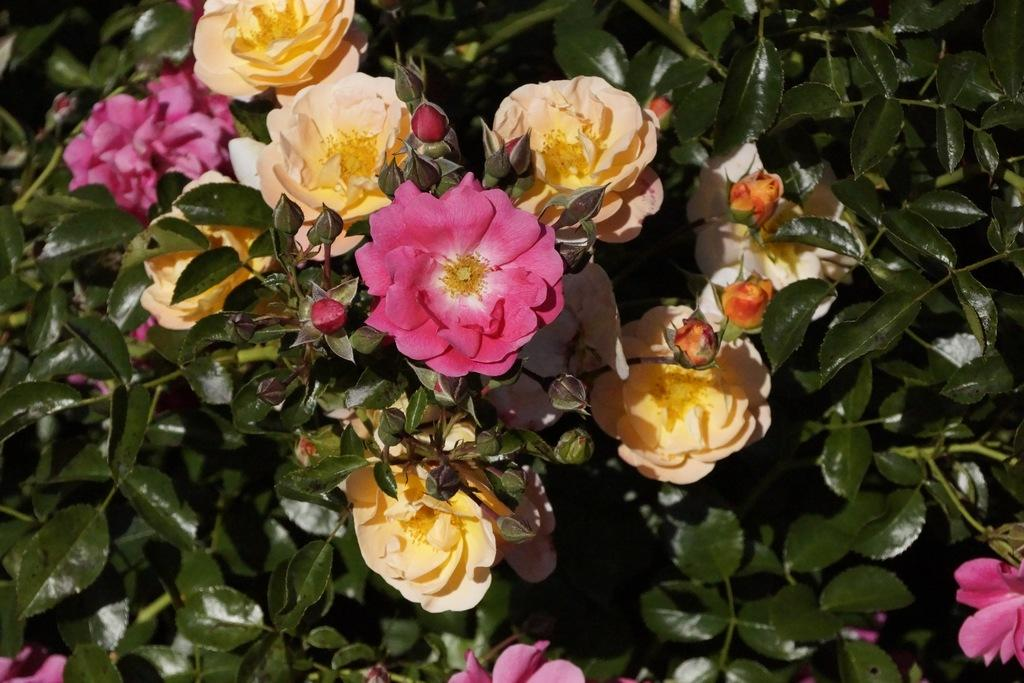What type of plants can be seen in the image? There are colorful flowers in the image. Can you describe the stage of growth for some of the flowers? Yes, there are buds in the image. What color are the leaves of the plants in the image? The leaves in the image are green. Who is the expert helping with the air conditioning in the image? There is no expert or air conditioning present in the image; it features colorful flowers, buds, and green leaves. 